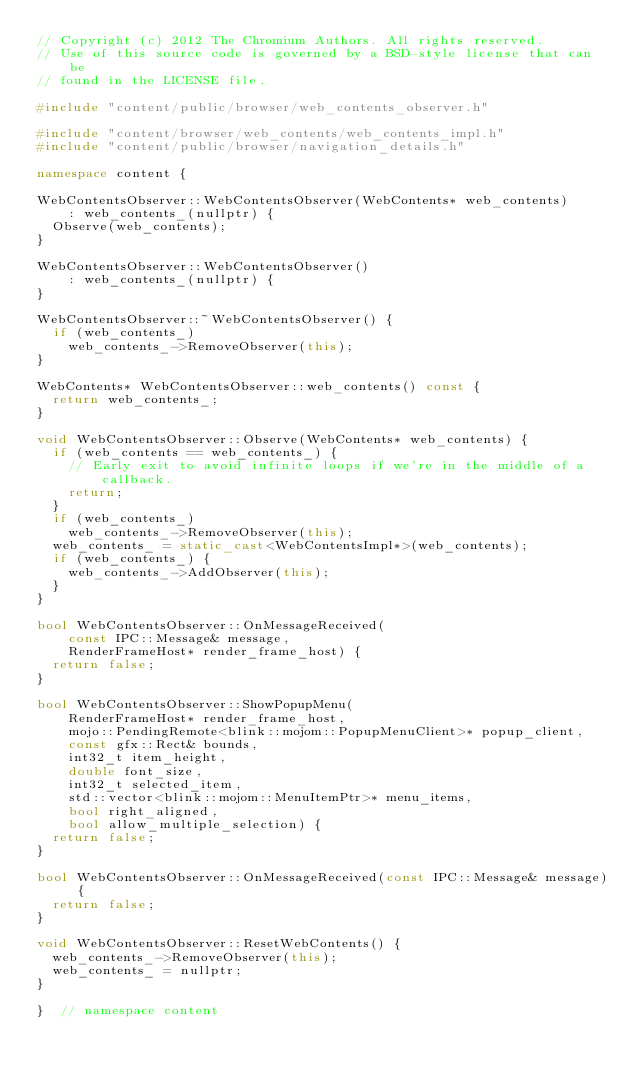Convert code to text. <code><loc_0><loc_0><loc_500><loc_500><_C++_>// Copyright (c) 2012 The Chromium Authors. All rights reserved.
// Use of this source code is governed by a BSD-style license that can be
// found in the LICENSE file.

#include "content/public/browser/web_contents_observer.h"

#include "content/browser/web_contents/web_contents_impl.h"
#include "content/public/browser/navigation_details.h"

namespace content {

WebContentsObserver::WebContentsObserver(WebContents* web_contents)
    : web_contents_(nullptr) {
  Observe(web_contents);
}

WebContentsObserver::WebContentsObserver()
    : web_contents_(nullptr) {
}

WebContentsObserver::~WebContentsObserver() {
  if (web_contents_)
    web_contents_->RemoveObserver(this);
}

WebContents* WebContentsObserver::web_contents() const {
  return web_contents_;
}

void WebContentsObserver::Observe(WebContents* web_contents) {
  if (web_contents == web_contents_) {
    // Early exit to avoid infinite loops if we're in the middle of a callback.
    return;
  }
  if (web_contents_)
    web_contents_->RemoveObserver(this);
  web_contents_ = static_cast<WebContentsImpl*>(web_contents);
  if (web_contents_) {
    web_contents_->AddObserver(this);
  }
}

bool WebContentsObserver::OnMessageReceived(
    const IPC::Message& message,
    RenderFrameHost* render_frame_host) {
  return false;
}

bool WebContentsObserver::ShowPopupMenu(
    RenderFrameHost* render_frame_host,
    mojo::PendingRemote<blink::mojom::PopupMenuClient>* popup_client,
    const gfx::Rect& bounds,
    int32_t item_height,
    double font_size,
    int32_t selected_item,
    std::vector<blink::mojom::MenuItemPtr>* menu_items,
    bool right_aligned,
    bool allow_multiple_selection) {
  return false;
}

bool WebContentsObserver::OnMessageReceived(const IPC::Message& message) {
  return false;
}

void WebContentsObserver::ResetWebContents() {
  web_contents_->RemoveObserver(this);
  web_contents_ = nullptr;
}

}  // namespace content
</code> 